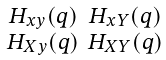<formula> <loc_0><loc_0><loc_500><loc_500>\begin{smallmatrix} H _ { x y } ( q ) & H _ { x Y } ( q ) \\ H _ { X y } ( q ) & H _ { X Y } ( q ) \end{smallmatrix}</formula> 